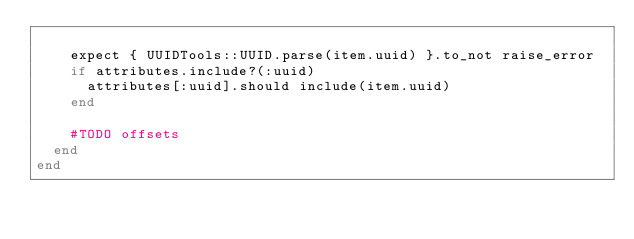<code> <loc_0><loc_0><loc_500><loc_500><_Ruby_>
    expect { UUIDTools::UUID.parse(item.uuid) }.to_not raise_error
    if attributes.include?(:uuid)
      attributes[:uuid].should include(item.uuid)
    end

    #TODO offsets
  end
end
</code> 